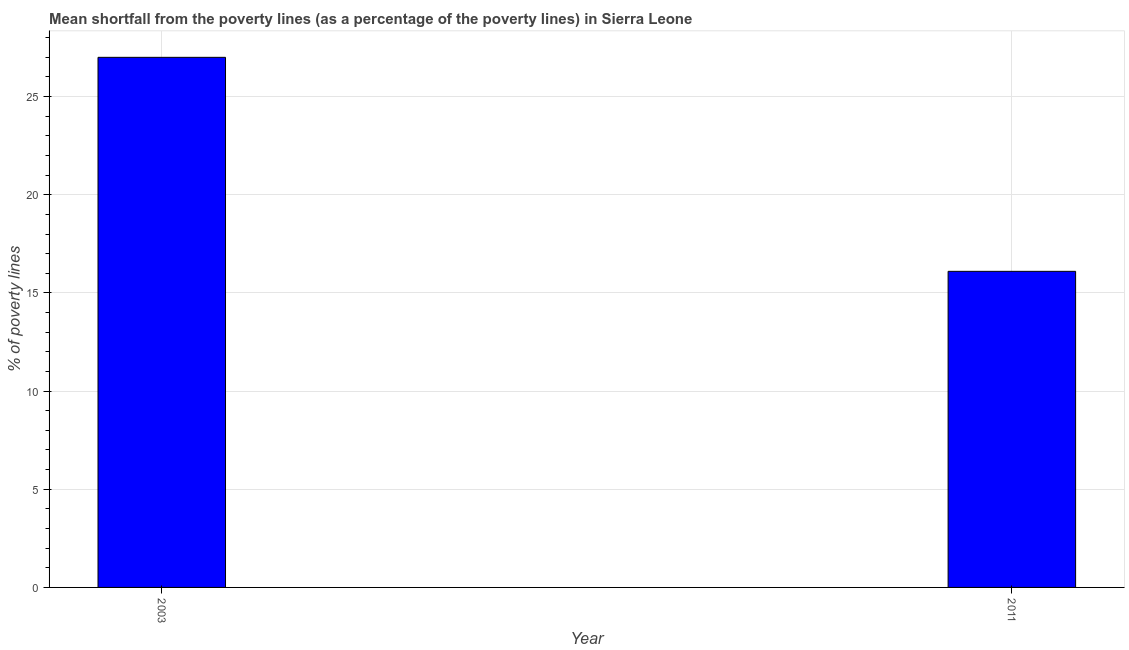Does the graph contain grids?
Provide a short and direct response. Yes. What is the title of the graph?
Make the answer very short. Mean shortfall from the poverty lines (as a percentage of the poverty lines) in Sierra Leone. What is the label or title of the X-axis?
Provide a succinct answer. Year. What is the label or title of the Y-axis?
Make the answer very short. % of poverty lines. What is the poverty gap at national poverty lines in 2003?
Your answer should be very brief. 27. Across all years, what is the maximum poverty gap at national poverty lines?
Your answer should be very brief. 27. Across all years, what is the minimum poverty gap at national poverty lines?
Ensure brevity in your answer.  16.1. In which year was the poverty gap at national poverty lines maximum?
Your answer should be compact. 2003. In which year was the poverty gap at national poverty lines minimum?
Provide a short and direct response. 2011. What is the sum of the poverty gap at national poverty lines?
Make the answer very short. 43.1. What is the average poverty gap at national poverty lines per year?
Offer a terse response. 21.55. What is the median poverty gap at national poverty lines?
Your answer should be compact. 21.55. In how many years, is the poverty gap at national poverty lines greater than 25 %?
Ensure brevity in your answer.  1. Do a majority of the years between 2003 and 2011 (inclusive) have poverty gap at national poverty lines greater than 9 %?
Offer a terse response. Yes. What is the ratio of the poverty gap at national poverty lines in 2003 to that in 2011?
Ensure brevity in your answer.  1.68. What is the % of poverty lines in 2003?
Offer a very short reply. 27. What is the difference between the % of poverty lines in 2003 and 2011?
Your response must be concise. 10.9. What is the ratio of the % of poverty lines in 2003 to that in 2011?
Offer a terse response. 1.68. 